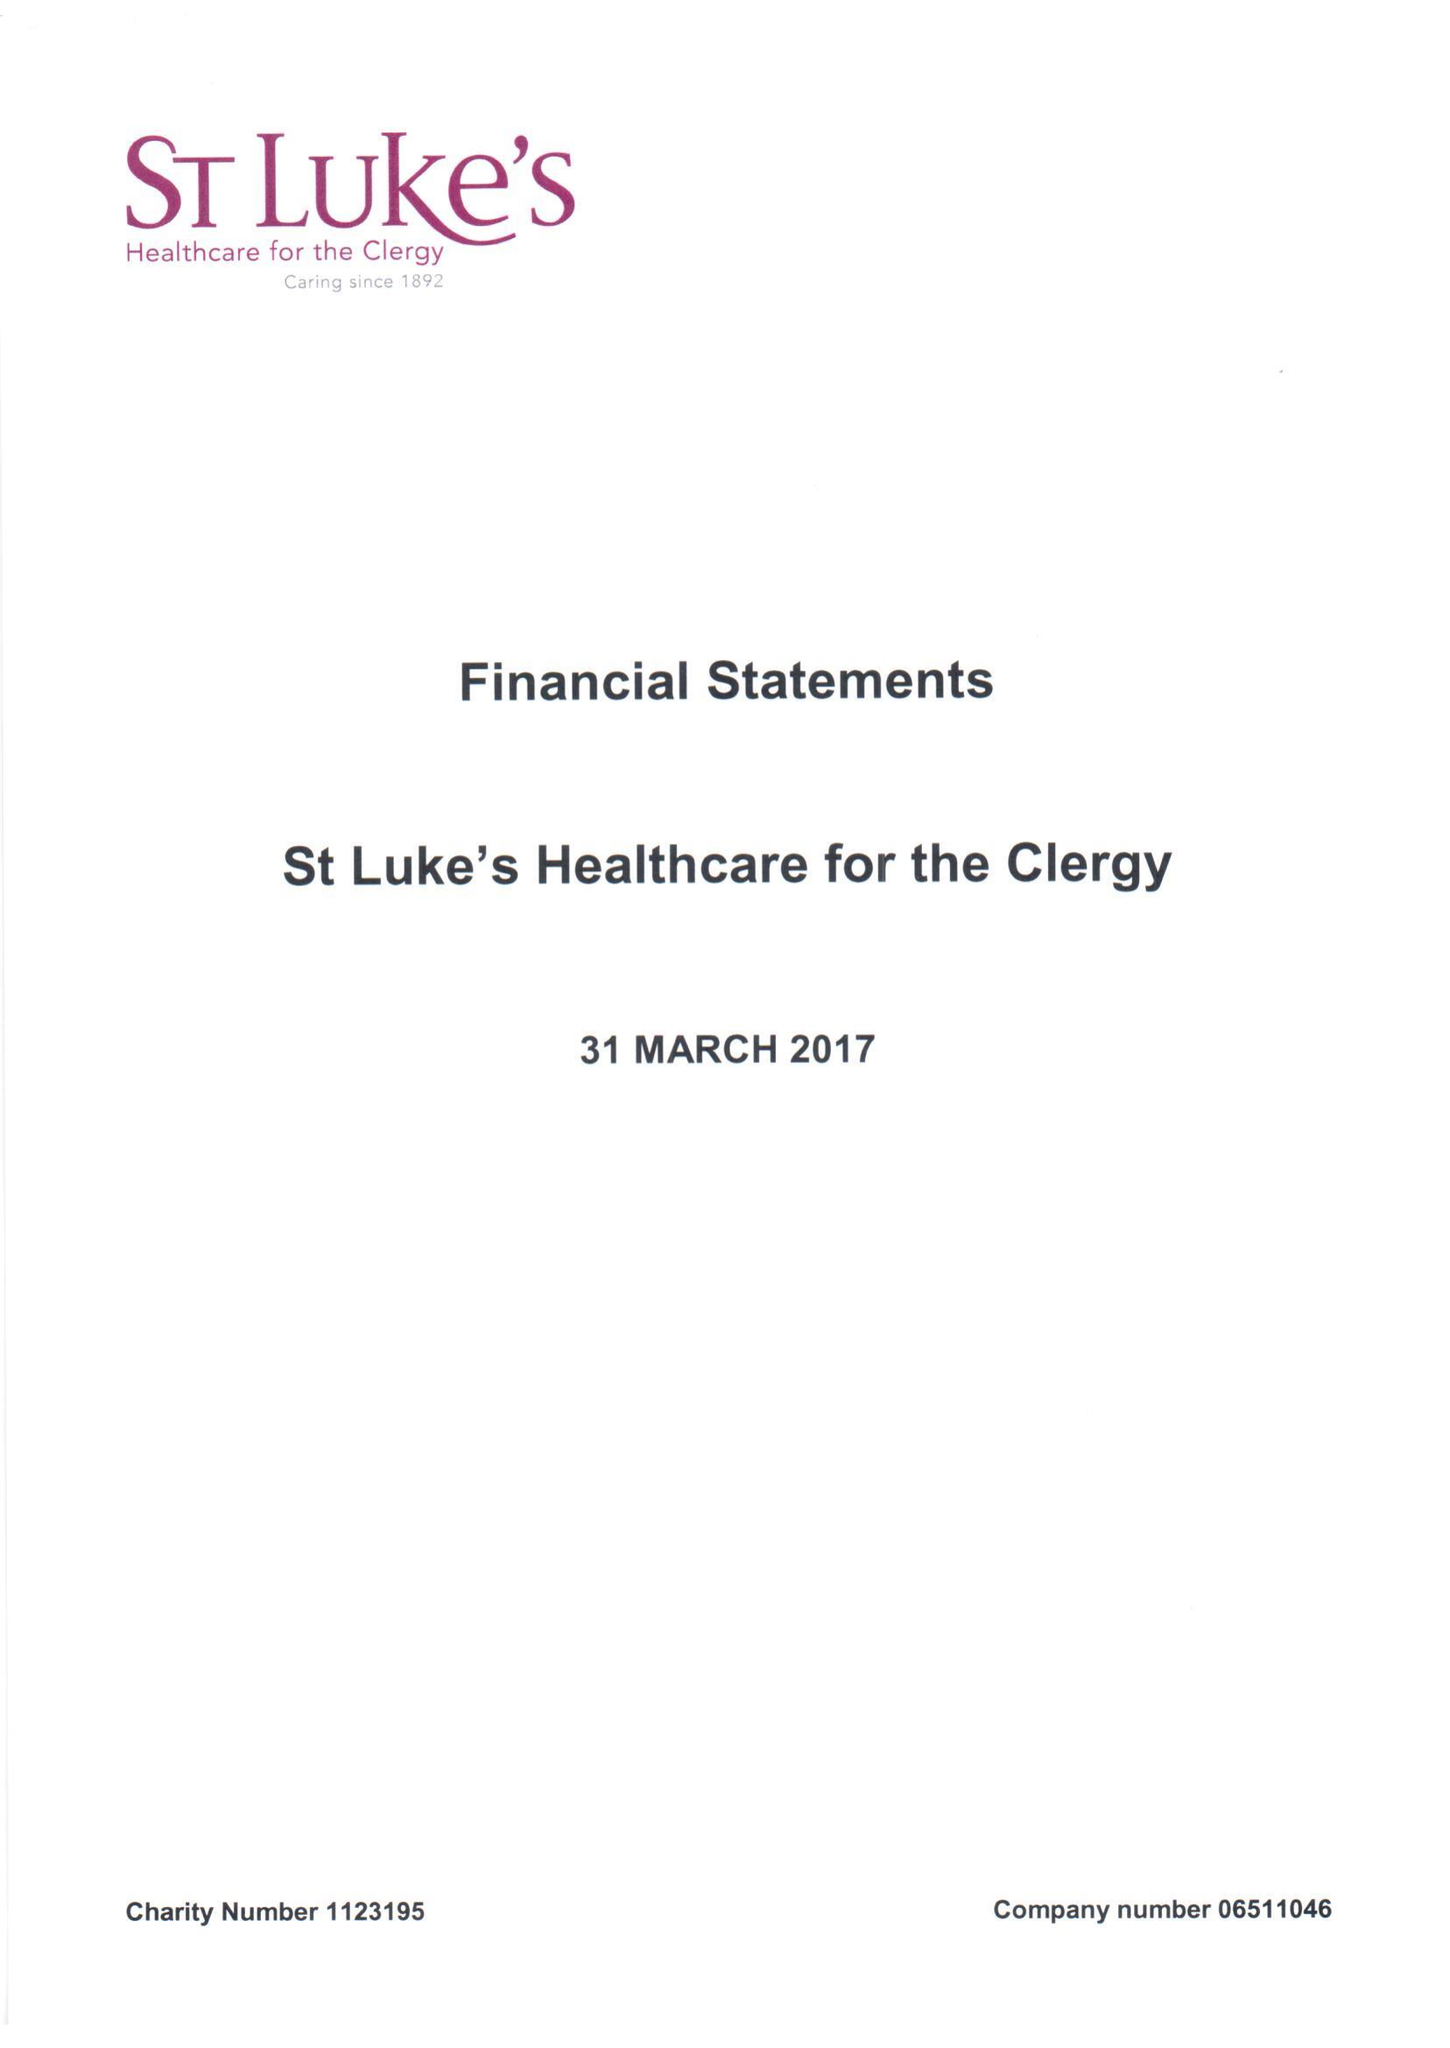What is the value for the income_annually_in_british_pounds?
Answer the question using a single word or phrase. 409008.00 